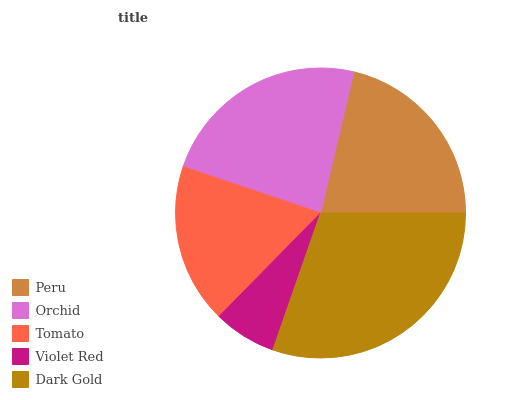Is Violet Red the minimum?
Answer yes or no. Yes. Is Dark Gold the maximum?
Answer yes or no. Yes. Is Orchid the minimum?
Answer yes or no. No. Is Orchid the maximum?
Answer yes or no. No. Is Orchid greater than Peru?
Answer yes or no. Yes. Is Peru less than Orchid?
Answer yes or no. Yes. Is Peru greater than Orchid?
Answer yes or no. No. Is Orchid less than Peru?
Answer yes or no. No. Is Peru the high median?
Answer yes or no. Yes. Is Peru the low median?
Answer yes or no. Yes. Is Violet Red the high median?
Answer yes or no. No. Is Orchid the low median?
Answer yes or no. No. 